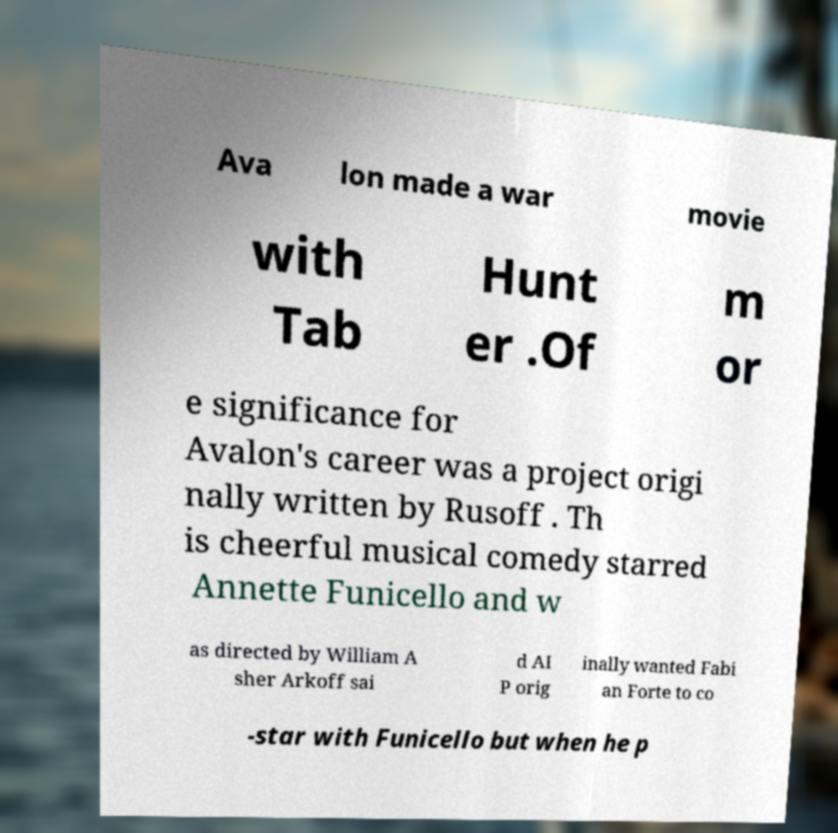Please read and relay the text visible in this image. What does it say? Ava lon made a war movie with Tab Hunt er .Of m or e significance for Avalon's career was a project origi nally written by Rusoff . Th is cheerful musical comedy starred Annette Funicello and w as directed by William A sher Arkoff sai d AI P orig inally wanted Fabi an Forte to co -star with Funicello but when he p 